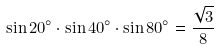Convert formula to latex. <formula><loc_0><loc_0><loc_500><loc_500>\sin 2 0 ^ { \circ } \cdot \sin 4 0 ^ { \circ } \cdot \sin 8 0 ^ { \circ } = { \frac { \sqrt { 3 } } { 8 } }</formula> 